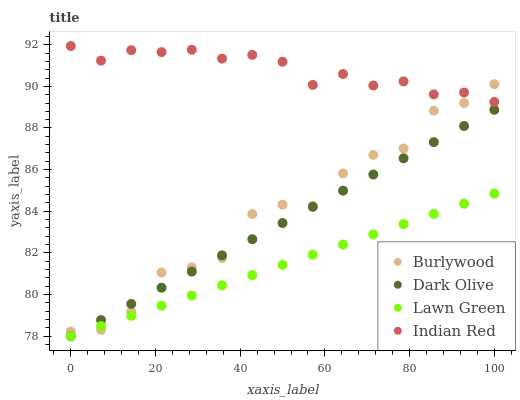Does Lawn Green have the minimum area under the curve?
Answer yes or no. Yes. Does Indian Red have the maximum area under the curve?
Answer yes or no. Yes. Does Dark Olive have the minimum area under the curve?
Answer yes or no. No. Does Dark Olive have the maximum area under the curve?
Answer yes or no. No. Is Dark Olive the smoothest?
Answer yes or no. Yes. Is Burlywood the roughest?
Answer yes or no. Yes. Is Lawn Green the smoothest?
Answer yes or no. No. Is Lawn Green the roughest?
Answer yes or no. No. Does Lawn Green have the lowest value?
Answer yes or no. Yes. Does Indian Red have the lowest value?
Answer yes or no. No. Does Indian Red have the highest value?
Answer yes or no. Yes. Does Dark Olive have the highest value?
Answer yes or no. No. Is Lawn Green less than Indian Red?
Answer yes or no. Yes. Is Indian Red greater than Lawn Green?
Answer yes or no. Yes. Does Lawn Green intersect Dark Olive?
Answer yes or no. Yes. Is Lawn Green less than Dark Olive?
Answer yes or no. No. Is Lawn Green greater than Dark Olive?
Answer yes or no. No. Does Lawn Green intersect Indian Red?
Answer yes or no. No. 